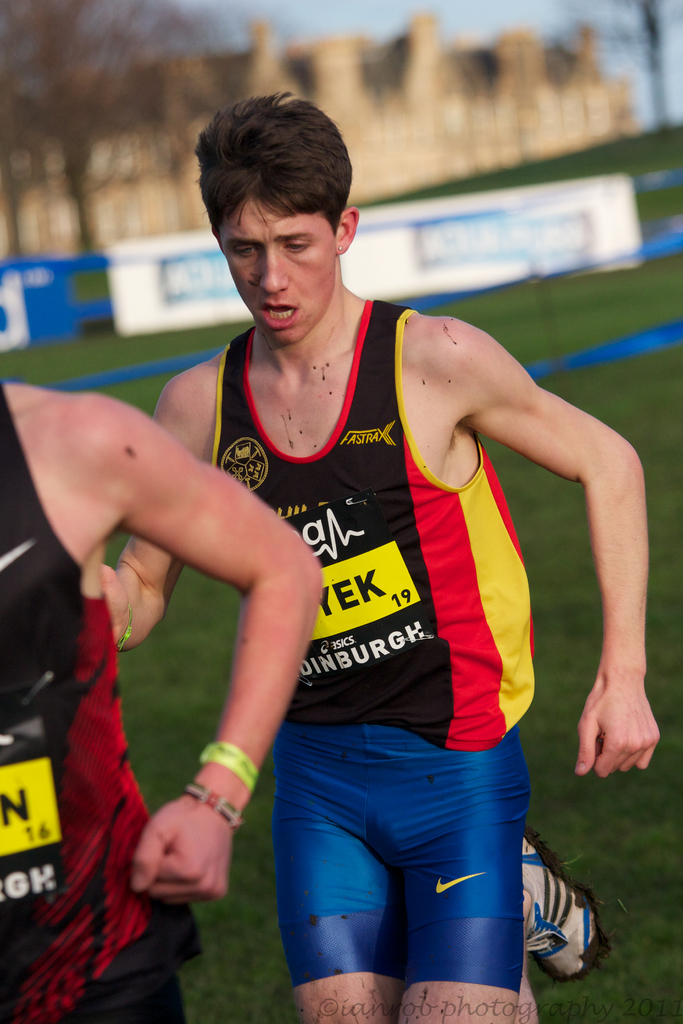What details can you provide about the setting of this event? The event is set in an outdoor, grassy area during what appears to be late afternoon, given the soft lighting. In the blurred background, you can see a historical castle, suggesting the event may be taking place in Edinburgh. The environment is chilly as indicated by the mud on the participants' attire, typical of cross-country events in potentially cold locations. 